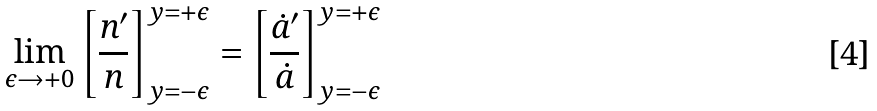<formula> <loc_0><loc_0><loc_500><loc_500>\lim _ { \epsilon \to + 0 } \left [ \frac { n ^ { \prime } } { n } \right ] _ { y = - \epsilon } ^ { y = + \epsilon } = \left [ \frac { \dot { a } ^ { \prime } } { \dot { a } } \right ] _ { y = - \epsilon } ^ { y = + \epsilon }</formula> 